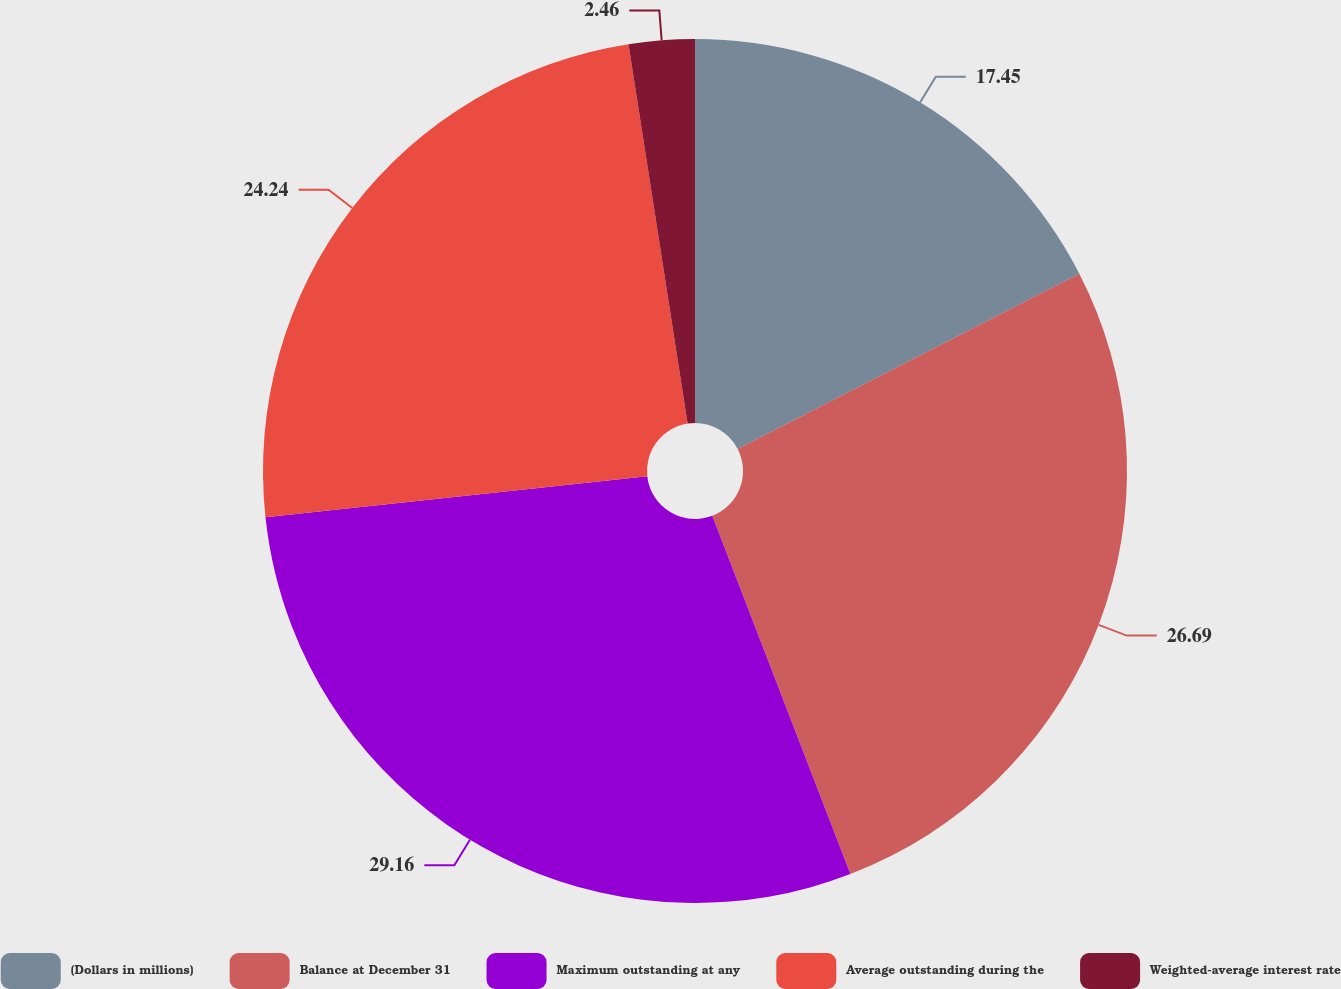Convert chart to OTSL. <chart><loc_0><loc_0><loc_500><loc_500><pie_chart><fcel>(Dollars in millions)<fcel>Balance at December 31<fcel>Maximum outstanding at any<fcel>Average outstanding during the<fcel>Weighted-average interest rate<nl><fcel>17.45%<fcel>26.69%<fcel>29.15%<fcel>24.24%<fcel>2.46%<nl></chart> 